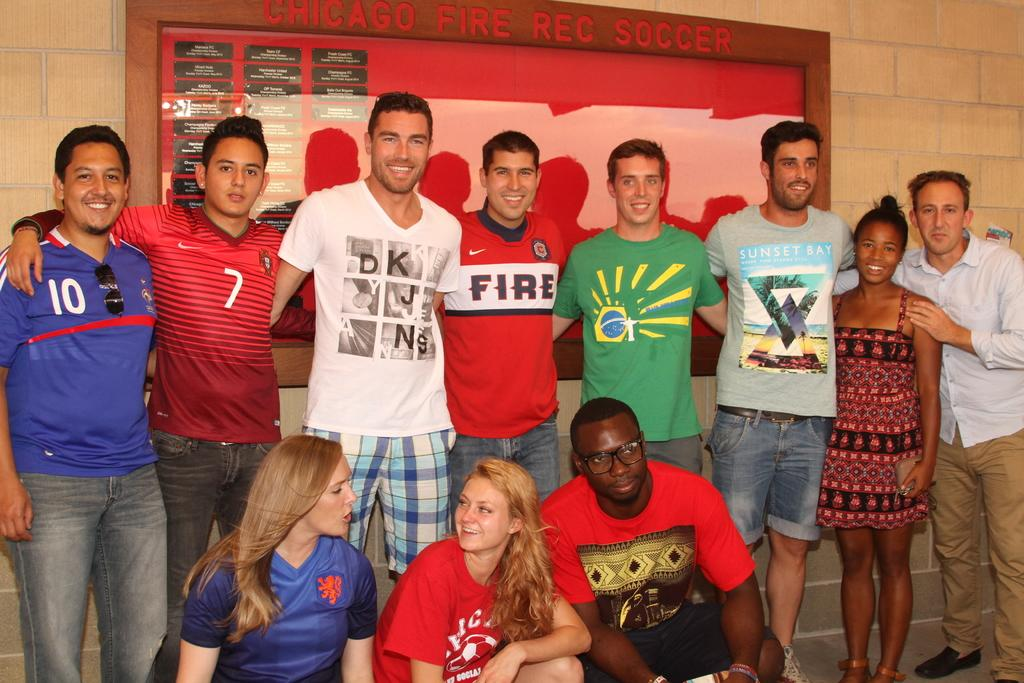What is the main subject of the image? The main subject of the image is a group of people. Where are the people located in the image? The people are standing in the center of the image. What can be seen in the background of the image? There is a poster in the background of the image. How many boys are visible in the image? The provided facts do not mention the gender of the people in the image, so it is impossible to determine the number of boys. 